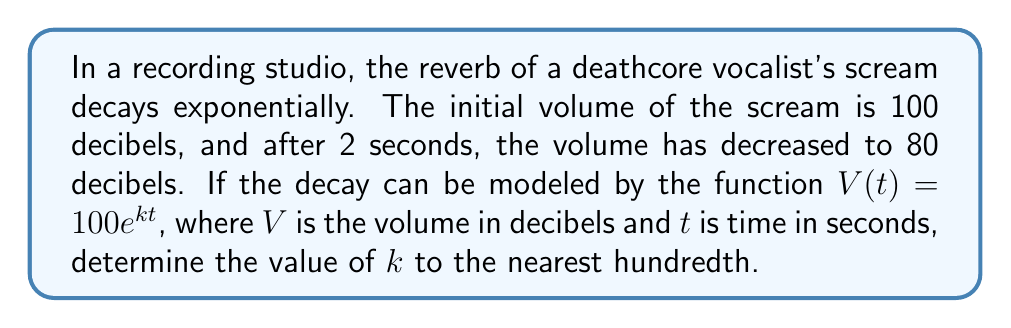Can you answer this question? Let's approach this step-by-step:

1) We're given the exponential function $V(t) = 100e^{kt}$, where:
   - $V$ is the volume in decibels
   - $t$ is time in seconds
   - $k$ is the decay constant we need to find
   - 100 is the initial volume

2) We know that after 2 seconds, the volume is 80 decibels. Let's use this information:

   $80 = 100e^{k(2)}$

3) Divide both sides by 100:

   $\frac{80}{100} = e^{2k}$

4) Take the natural log of both sides:

   $\ln(\frac{80}{100}) = \ln(e^{2k})$

5) Simplify the right side using the properties of logarithms:

   $\ln(0.8) = 2k$

6) Solve for $k$:

   $k = \frac{\ln(0.8)}{2}$

7) Use a calculator to evaluate:

   $k \approx -0.1115$

8) Rounding to the nearest hundredth:

   $k \approx -0.11$

The negative value indicates that the volume is decreasing over time, which is consistent with the decay of the reverb.
Answer: $-0.11$ 